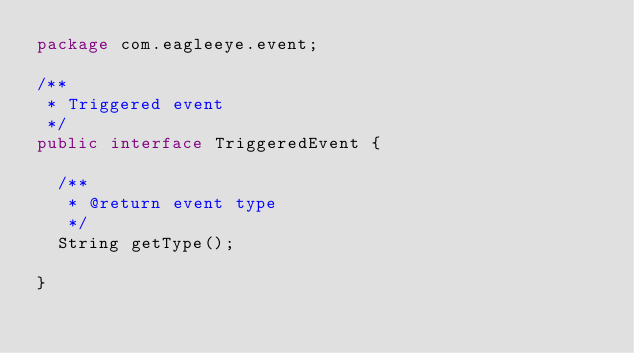<code> <loc_0><loc_0><loc_500><loc_500><_Java_>package com.eagleeye.event;

/**
 * Triggered event
 */
public interface TriggeredEvent {

  /**
   * @return event type
   */
  String getType();

}
</code> 